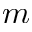Convert formula to latex. <formula><loc_0><loc_0><loc_500><loc_500>m</formula> 